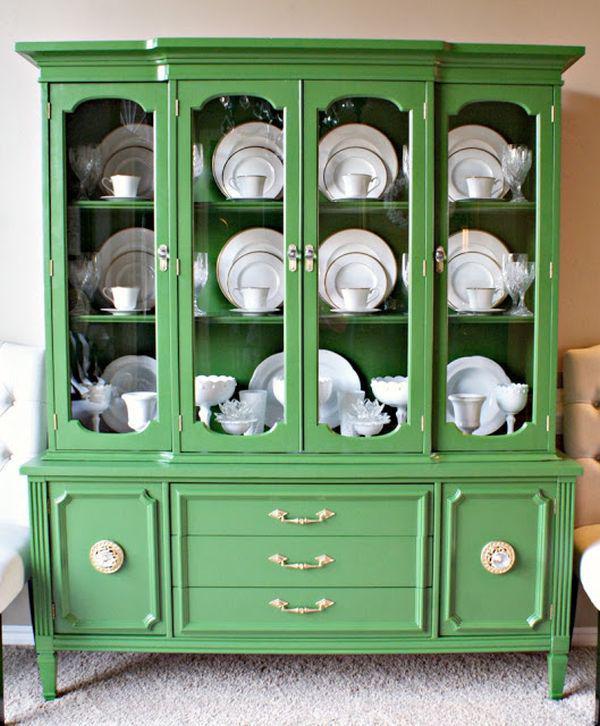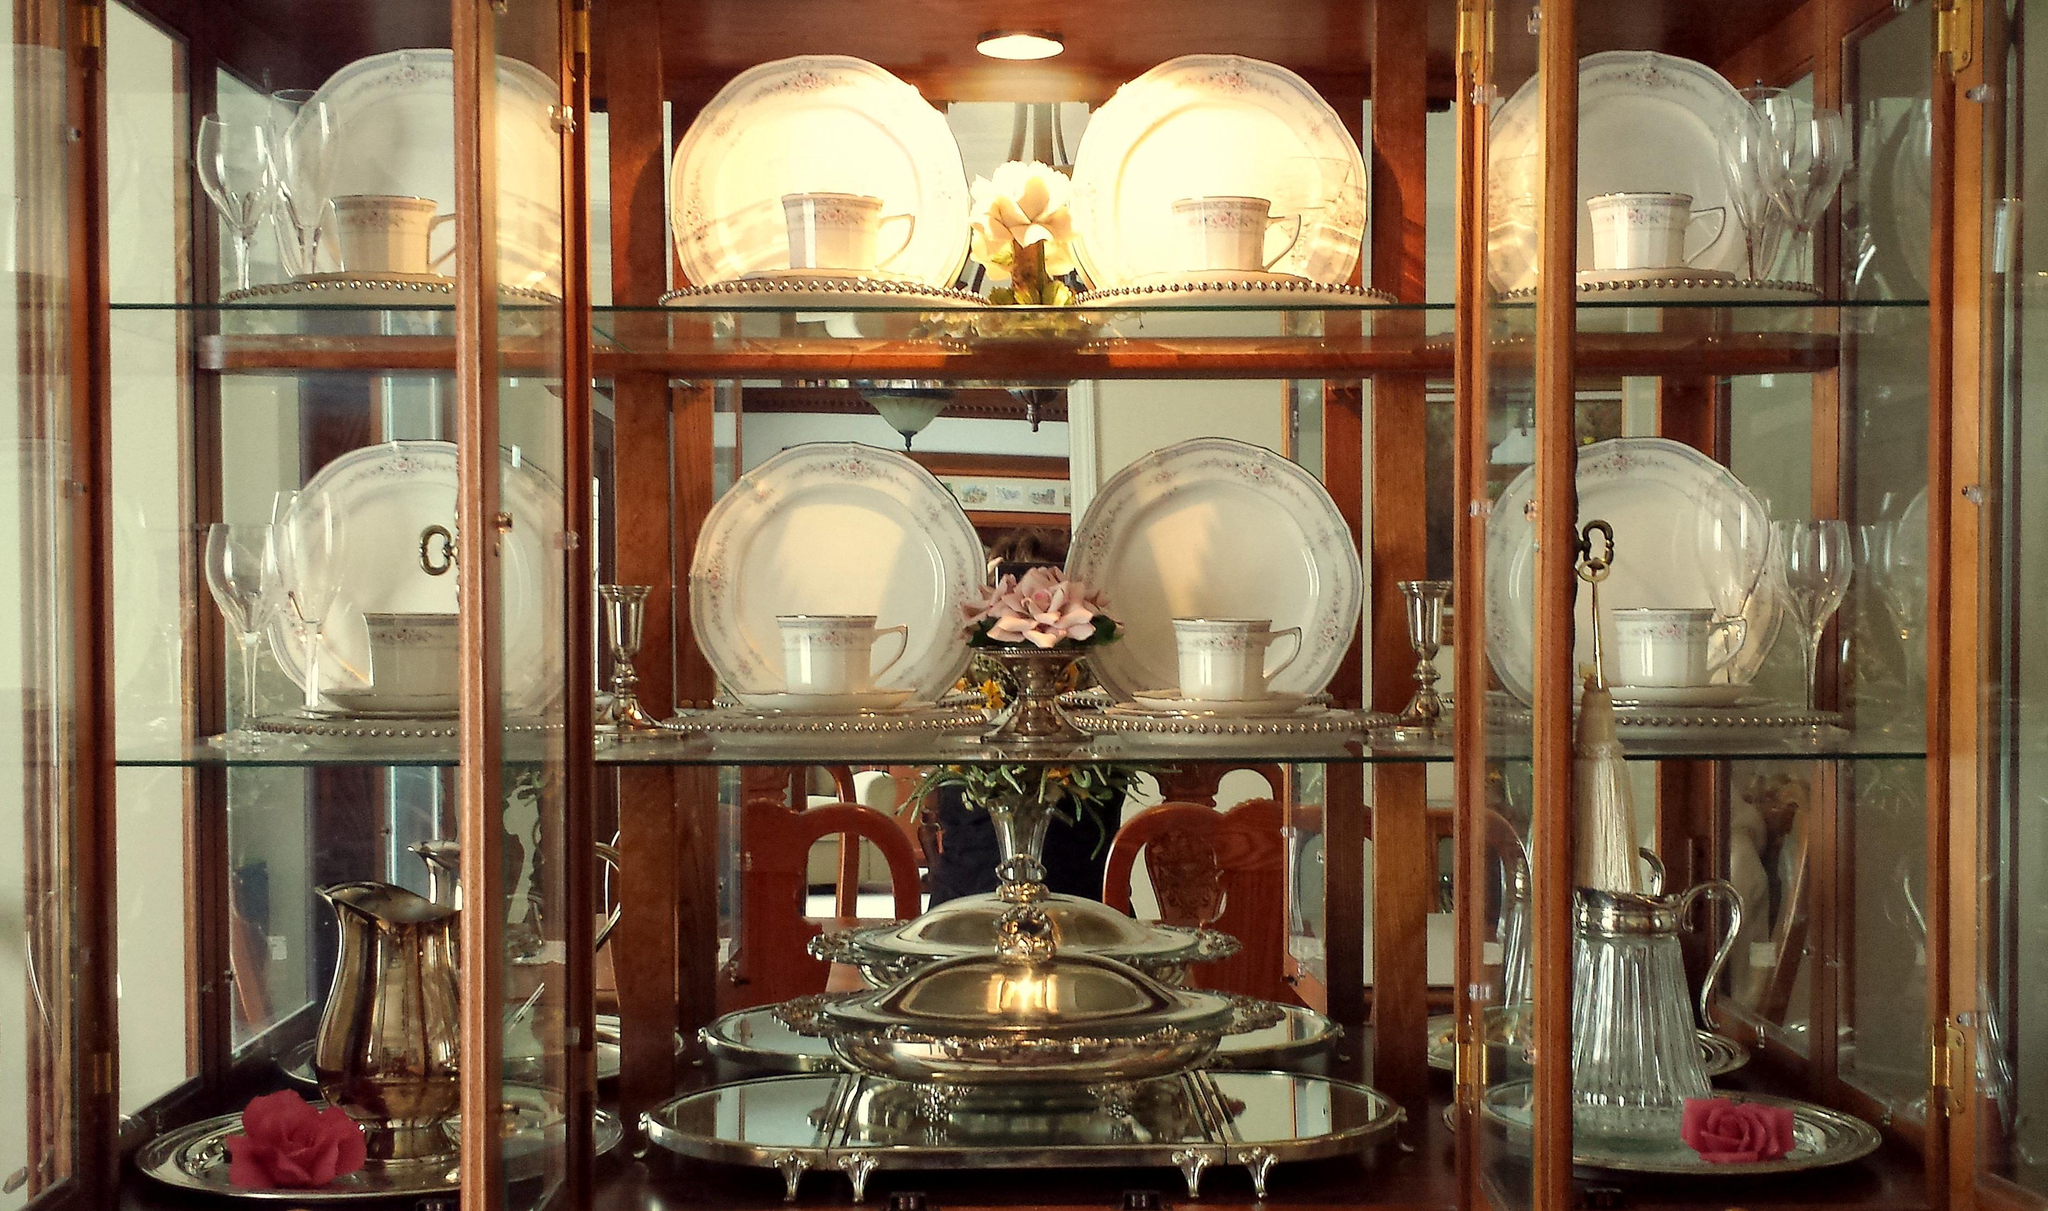The first image is the image on the left, the second image is the image on the right. Evaluate the accuracy of this statement regarding the images: "There are four plates on each shelf in the image on the left". Is it true? Answer yes or no. Yes. The first image is the image on the left, the second image is the image on the right. Examine the images to the left and right. Is the description "All furniture on the images are brown" accurate? Answer yes or no. No. 